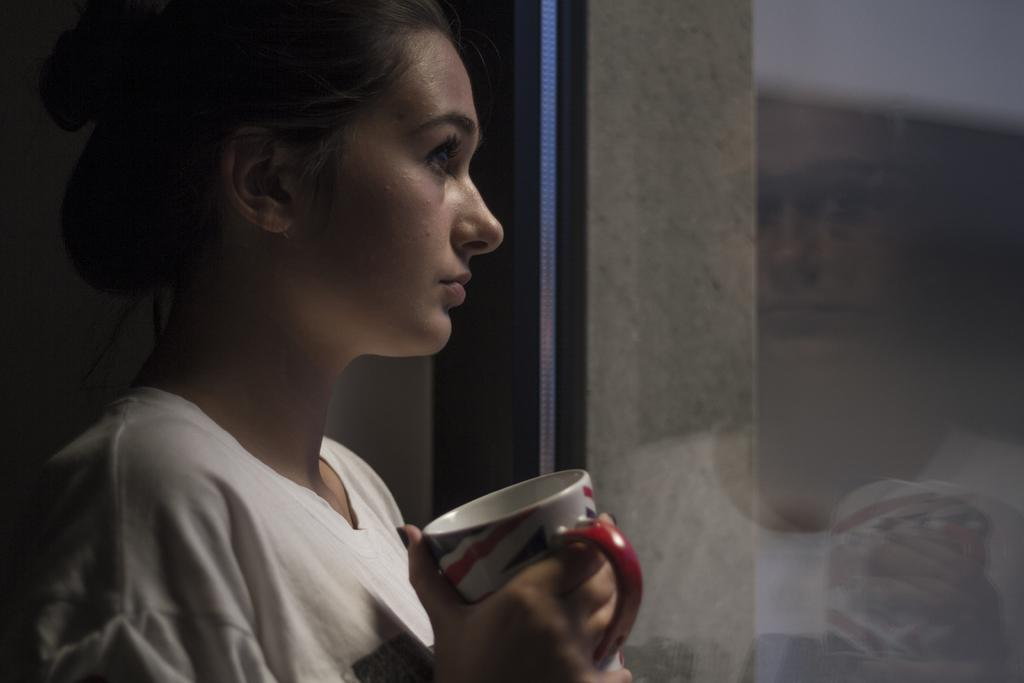Who is present in the image? There is a woman in the image. What is the woman holding in her hand? The woman is holding a cup in her hand. What color is the dress the woman is wearing? The woman is wearing a white color dress. What type of yarn is the woman using to knit in the image? There is no yarn or knitting activity present in the image. 